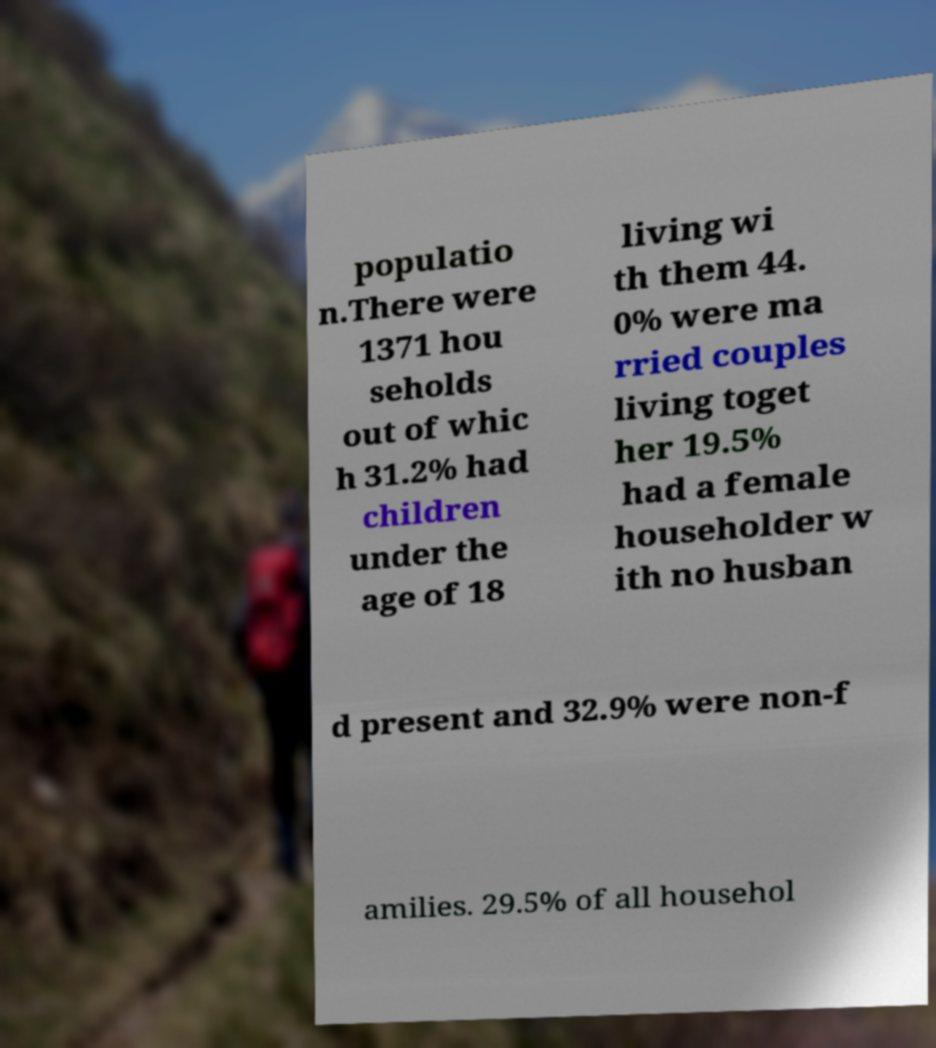Could you assist in decoding the text presented in this image and type it out clearly? populatio n.There were 1371 hou seholds out of whic h 31.2% had children under the age of 18 living wi th them 44. 0% were ma rried couples living toget her 19.5% had a female householder w ith no husban d present and 32.9% were non-f amilies. 29.5% of all househol 